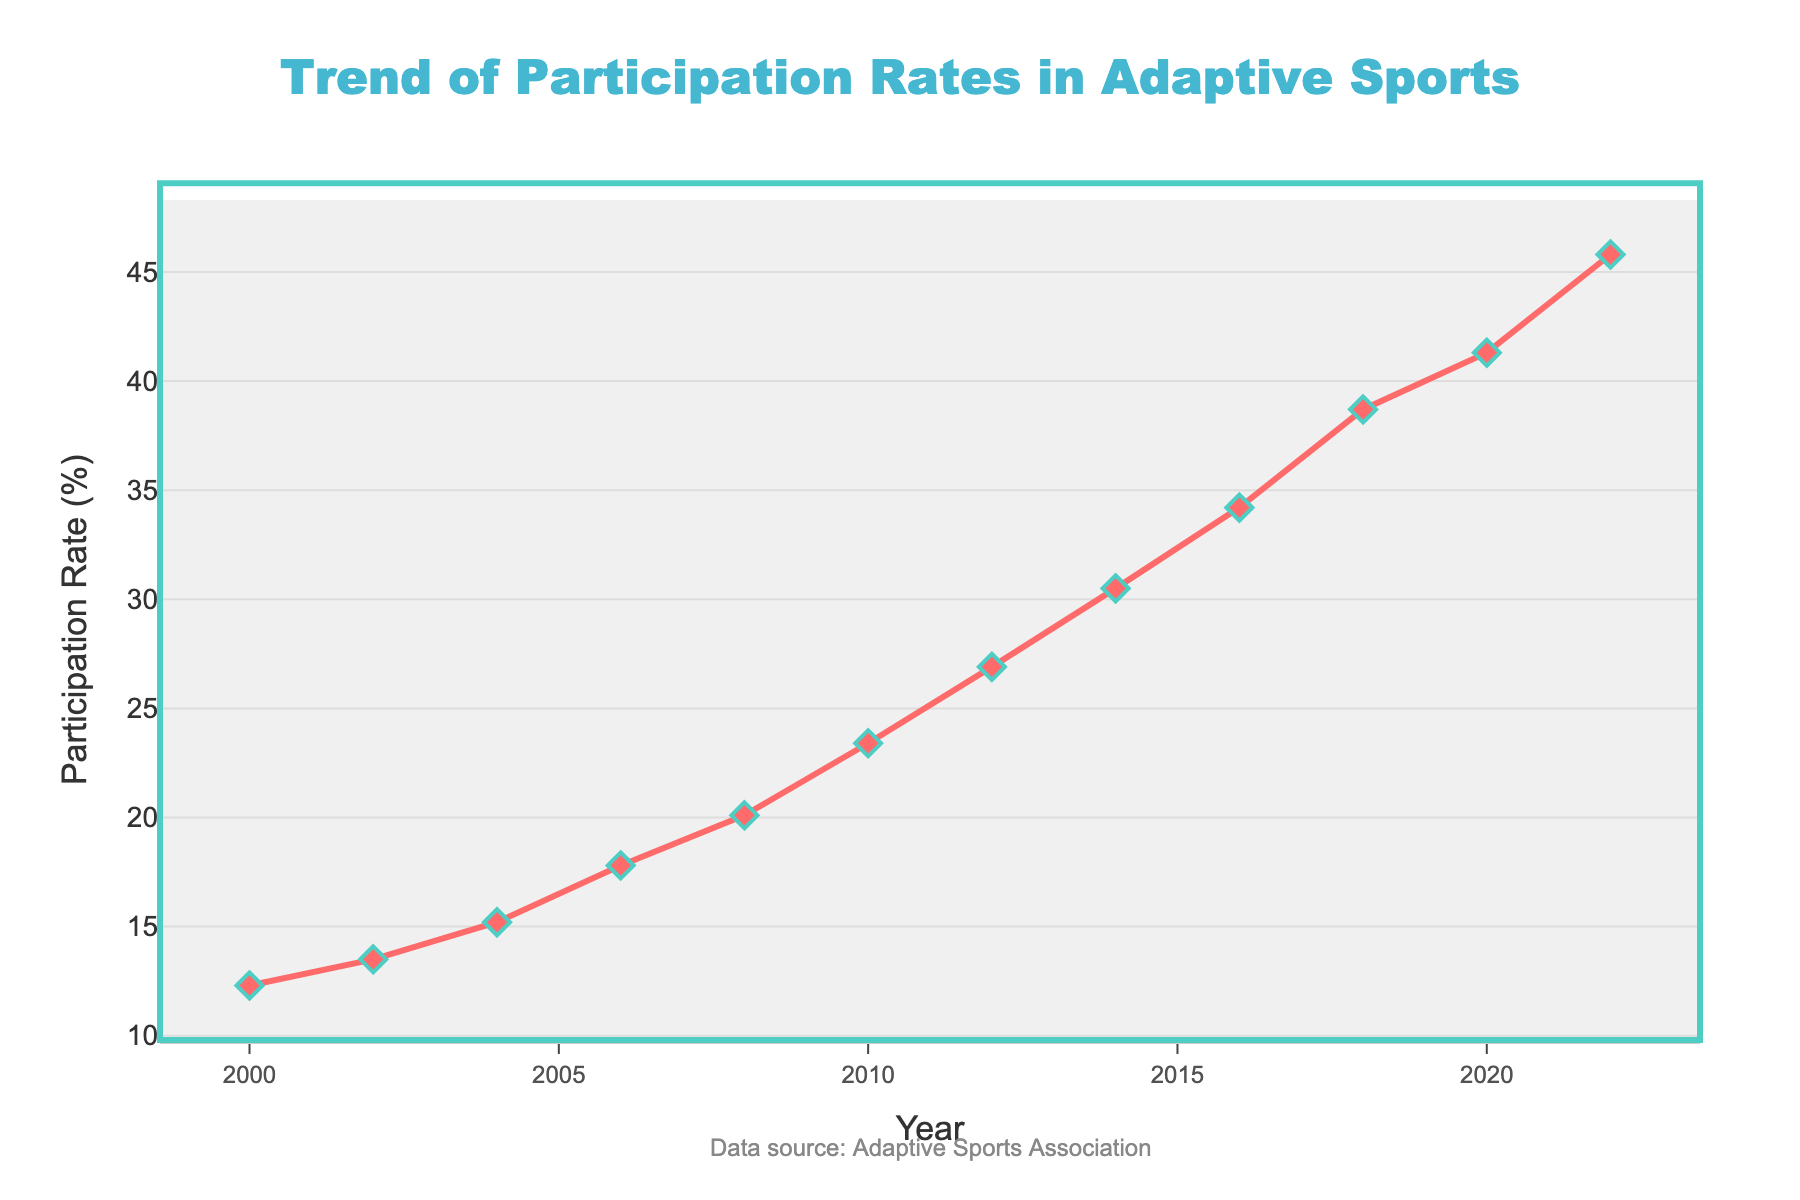Which year had the highest participation rate in adaptive sports? Look at the maximum point on the line chart. The highest value is at the year 2022 with a participation rate of 45.8%.
Answer: 2022 How much did the participation rate increase from 2000 to 2022? Subtract the participation rate in 2000 from the rate in 2022: 45.8% - 12.3% = 33.5%.
Answer: 33.5% What is the average participation rate from 2010 to 2022? Find the values from 2010 to 2022, sum them up and divide by the number of data points: (23.4 + 26.9 + 30.5 + 34.2 + 38.7 + 41.3 + 45.8) / 7 = 240.8 / 7 ≈ 34.4%.
Answer: 34.4% During which period did the participation rate see the highest increase? Look for the steepest slope between any two consecutive years, from 2018 to 2020 it increased from 38.7% to 41.3%, an increase of 2.6 percentage points.
Answer: 2018 to 2020 Did the participation rate double between any two points in time between 2000 and 2022? If so, which years? The participation rate in 2000 was 12.3%, and it doubled by 2012, reaching 26.9%.
Answer: 2000 to 2012 When did the participation rate first exceed 20%? Look at the line chart and find the first year where the rate goes above 20%, which is 2008.
Answer: 2008 By how much did the participation rate increase between 2000 and 2008? Subtract the participation rate in 2000 from the rate in 2008: 20.1% - 12.3% = 7.8%.
Answer: 7.8% What is the overall trend of participation rates from 2000 to 2022? Visually, the participation rates have been increasing steadily over the years.
Answer: Increasing How many years did it take for the participation rate to go from 12.3% to over 30%? Identify the years when the rates were 12.3% (2000) and just above 30% (2014), so it took 14 years.
Answer: 14 years 